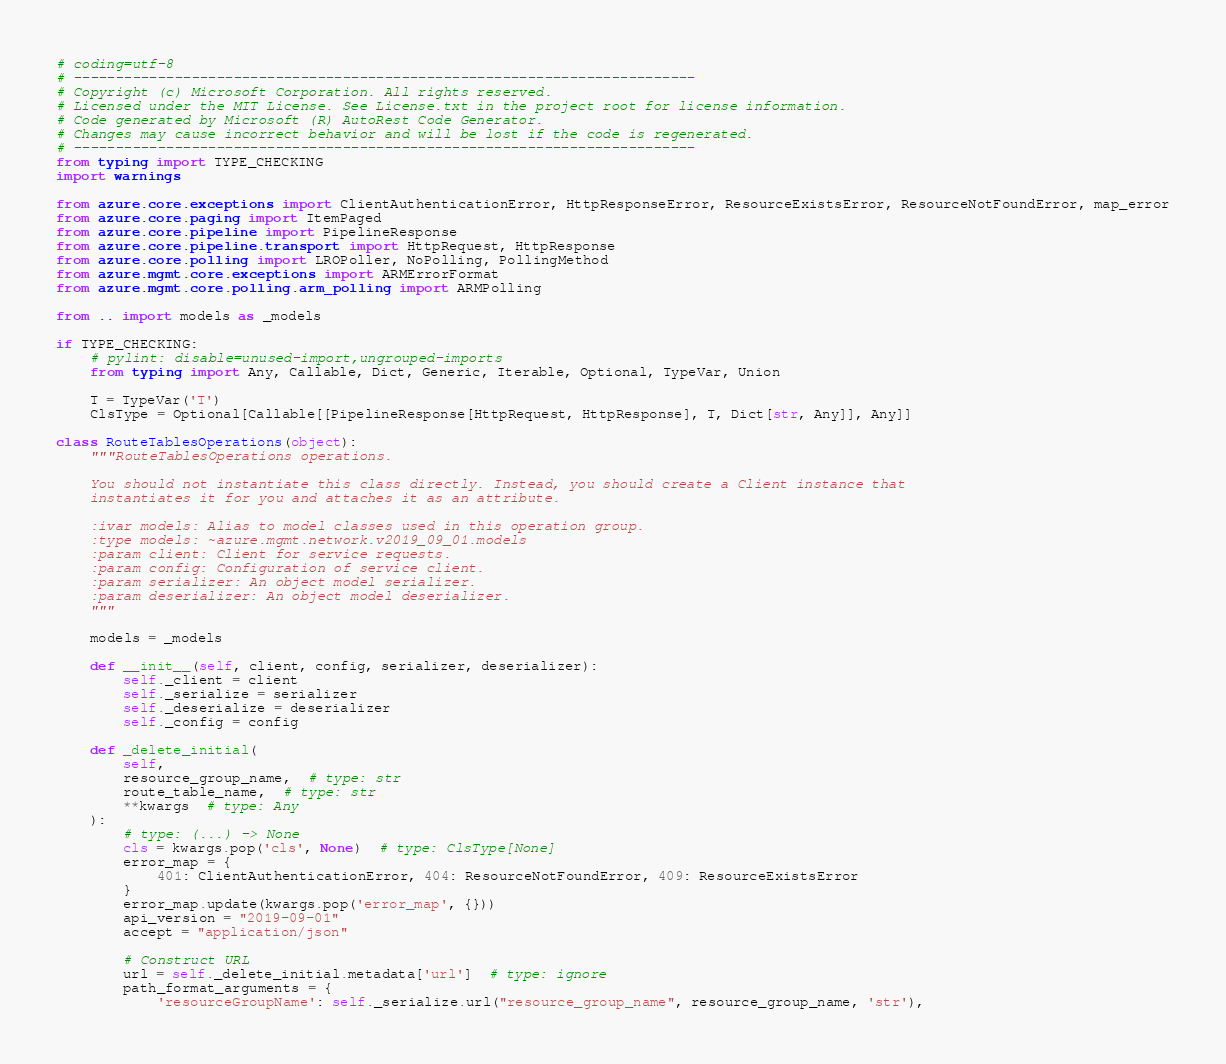Convert code to text. <code><loc_0><loc_0><loc_500><loc_500><_Python_># coding=utf-8
# --------------------------------------------------------------------------
# Copyright (c) Microsoft Corporation. All rights reserved.
# Licensed under the MIT License. See License.txt in the project root for license information.
# Code generated by Microsoft (R) AutoRest Code Generator.
# Changes may cause incorrect behavior and will be lost if the code is regenerated.
# --------------------------------------------------------------------------
from typing import TYPE_CHECKING
import warnings

from azure.core.exceptions import ClientAuthenticationError, HttpResponseError, ResourceExistsError, ResourceNotFoundError, map_error
from azure.core.paging import ItemPaged
from azure.core.pipeline import PipelineResponse
from azure.core.pipeline.transport import HttpRequest, HttpResponse
from azure.core.polling import LROPoller, NoPolling, PollingMethod
from azure.mgmt.core.exceptions import ARMErrorFormat
from azure.mgmt.core.polling.arm_polling import ARMPolling

from .. import models as _models

if TYPE_CHECKING:
    # pylint: disable=unused-import,ungrouped-imports
    from typing import Any, Callable, Dict, Generic, Iterable, Optional, TypeVar, Union

    T = TypeVar('T')
    ClsType = Optional[Callable[[PipelineResponse[HttpRequest, HttpResponse], T, Dict[str, Any]], Any]]

class RouteTablesOperations(object):
    """RouteTablesOperations operations.

    You should not instantiate this class directly. Instead, you should create a Client instance that
    instantiates it for you and attaches it as an attribute.

    :ivar models: Alias to model classes used in this operation group.
    :type models: ~azure.mgmt.network.v2019_09_01.models
    :param client: Client for service requests.
    :param config: Configuration of service client.
    :param serializer: An object model serializer.
    :param deserializer: An object model deserializer.
    """

    models = _models

    def __init__(self, client, config, serializer, deserializer):
        self._client = client
        self._serialize = serializer
        self._deserialize = deserializer
        self._config = config

    def _delete_initial(
        self,
        resource_group_name,  # type: str
        route_table_name,  # type: str
        **kwargs  # type: Any
    ):
        # type: (...) -> None
        cls = kwargs.pop('cls', None)  # type: ClsType[None]
        error_map = {
            401: ClientAuthenticationError, 404: ResourceNotFoundError, 409: ResourceExistsError
        }
        error_map.update(kwargs.pop('error_map', {}))
        api_version = "2019-09-01"
        accept = "application/json"

        # Construct URL
        url = self._delete_initial.metadata['url']  # type: ignore
        path_format_arguments = {
            'resourceGroupName': self._serialize.url("resource_group_name", resource_group_name, 'str'),</code> 